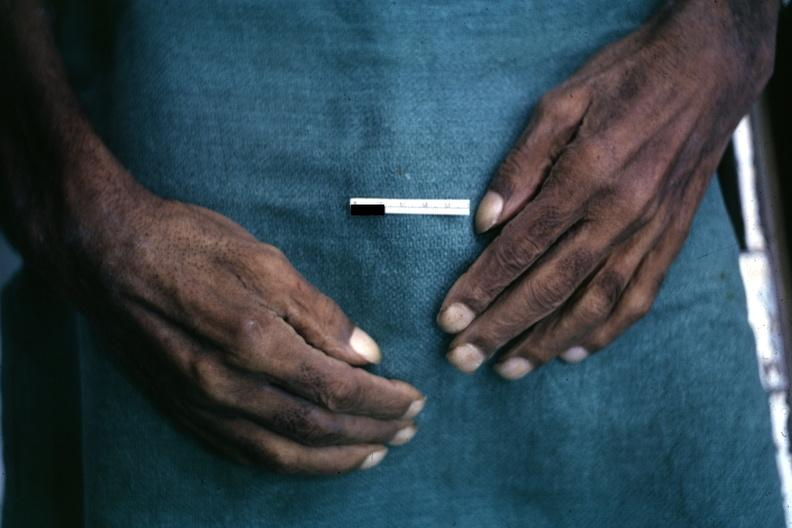s this typical lesion present?
Answer the question using a single word or phrase. No 